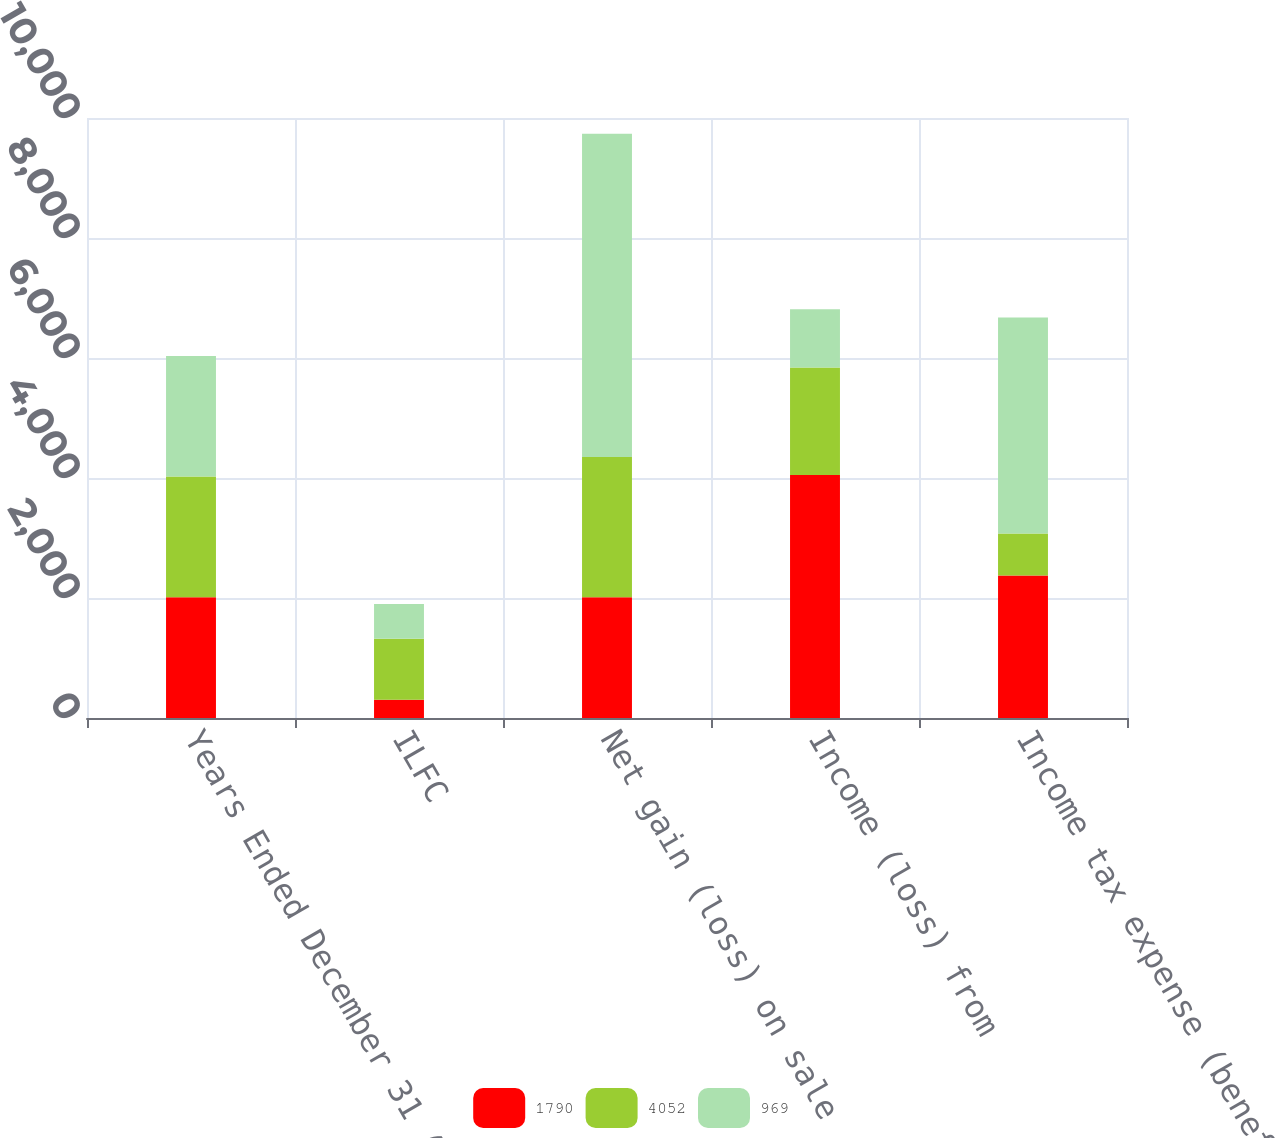Convert chart to OTSL. <chart><loc_0><loc_0><loc_500><loc_500><stacked_bar_chart><ecel><fcel>Years Ended December 31 (in<fcel>ILFC<fcel>Net gain (loss) on sale<fcel>Income (loss) from<fcel>Income tax expense (benefit)<nl><fcel>1790<fcel>2012<fcel>304<fcel>2012<fcel>4052<fcel>2377<nl><fcel>4052<fcel>2011<fcel>1017<fcel>2338<fcel>1790<fcel>698<nl><fcel>969<fcel>2010<fcel>581<fcel>5389<fcel>969<fcel>3599<nl></chart> 